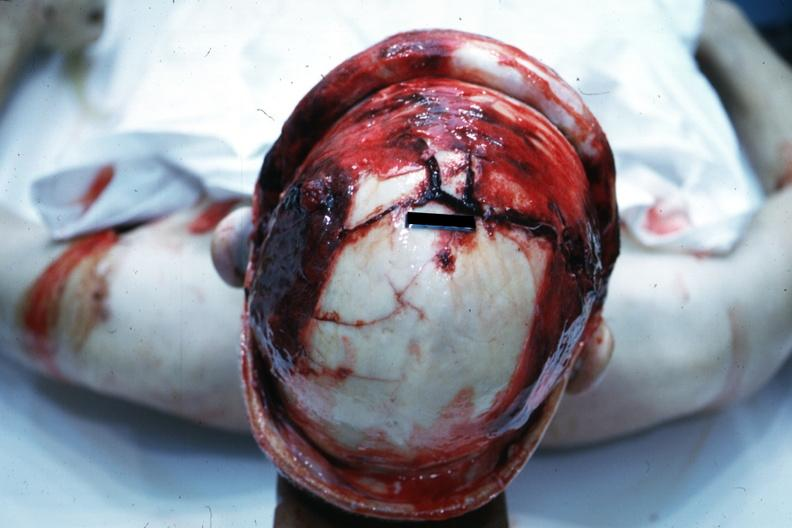what retracted to show massive fractures?
Answer the question using a single word or phrase. View of head with scalp 